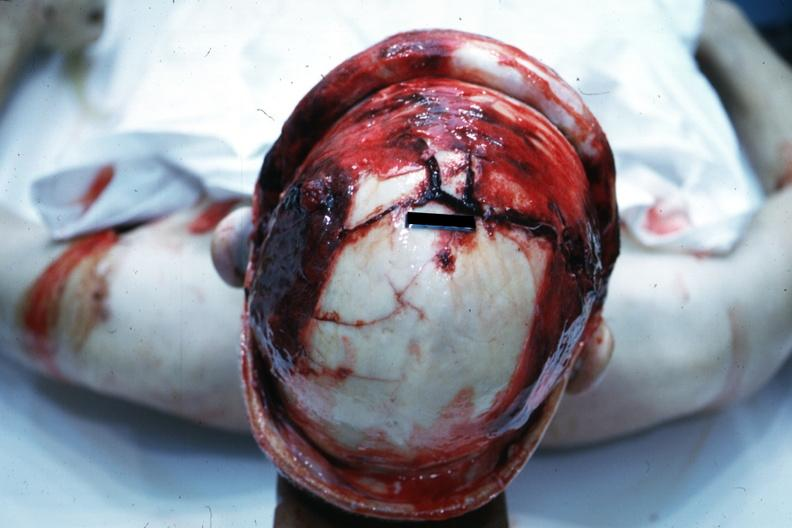what retracted to show massive fractures?
Answer the question using a single word or phrase. View of head with scalp 